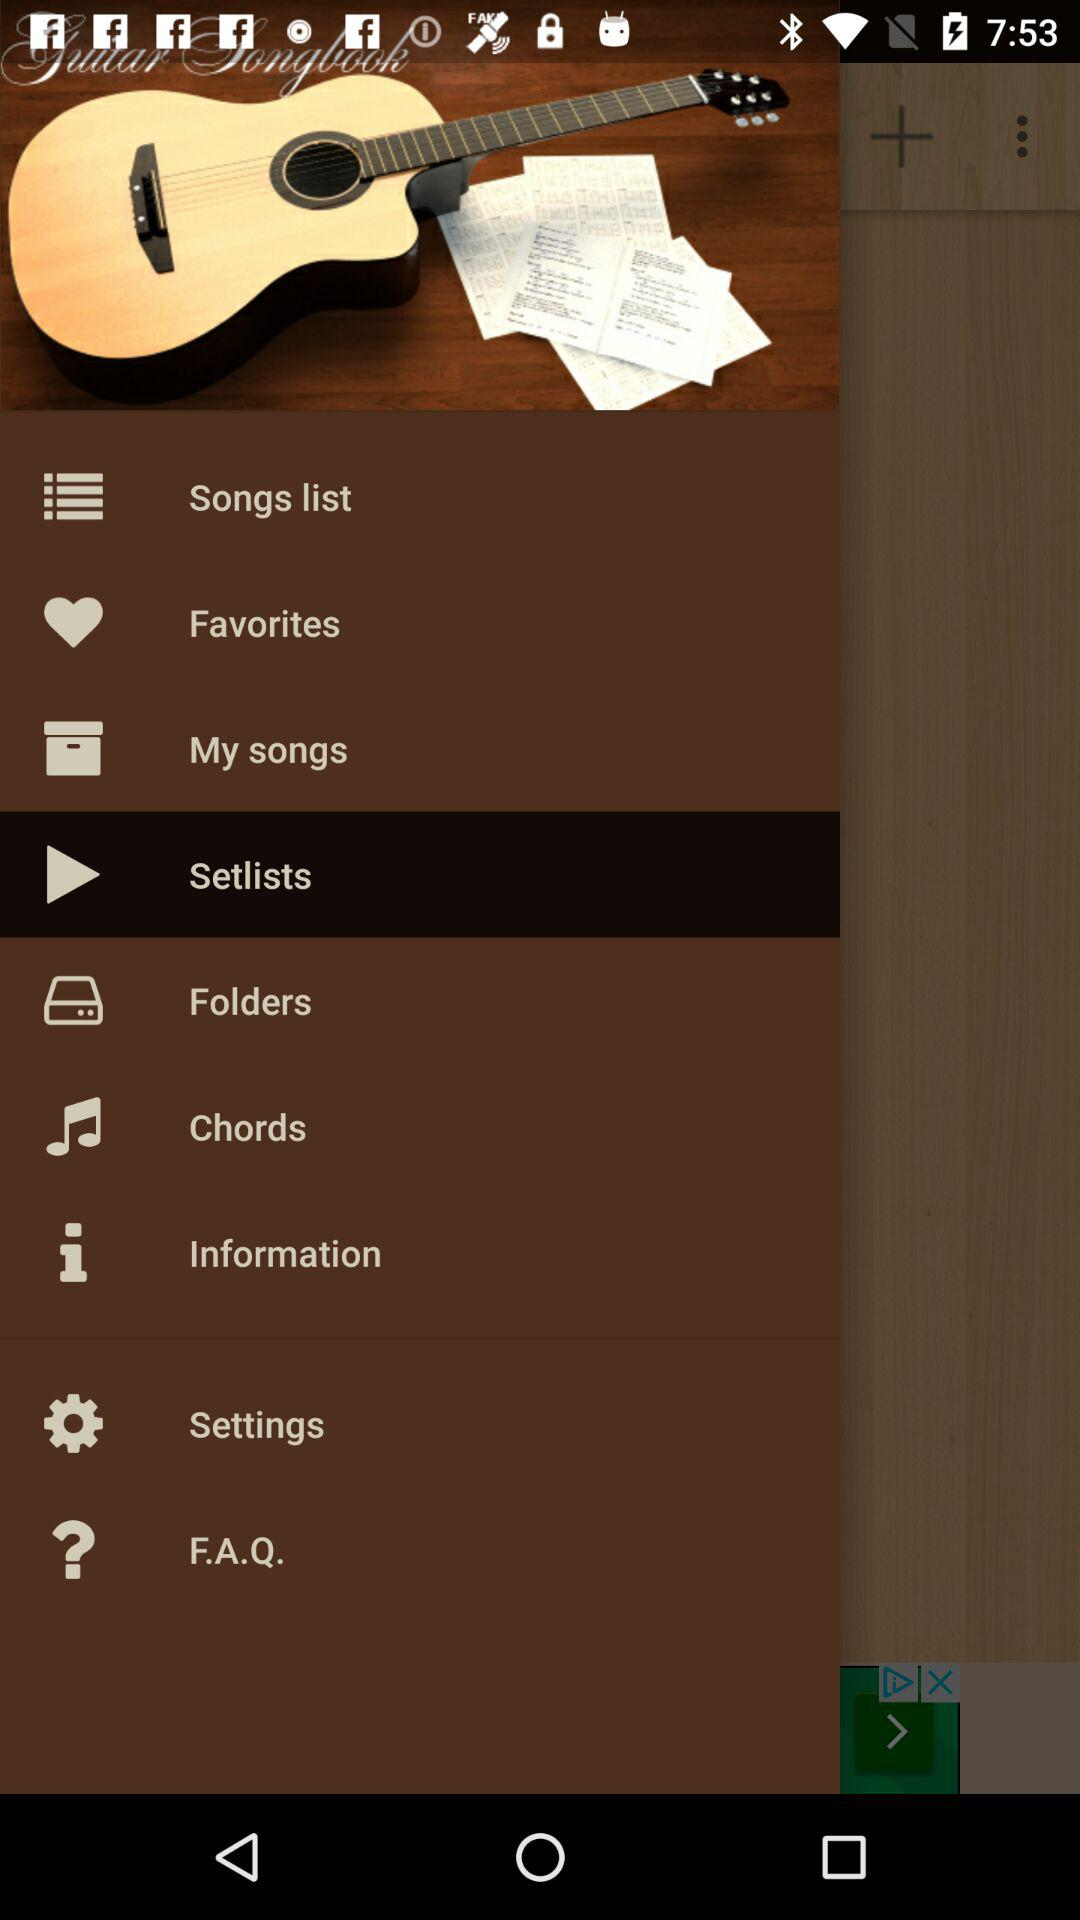Which item is selected? The selected item is "Setlists". 